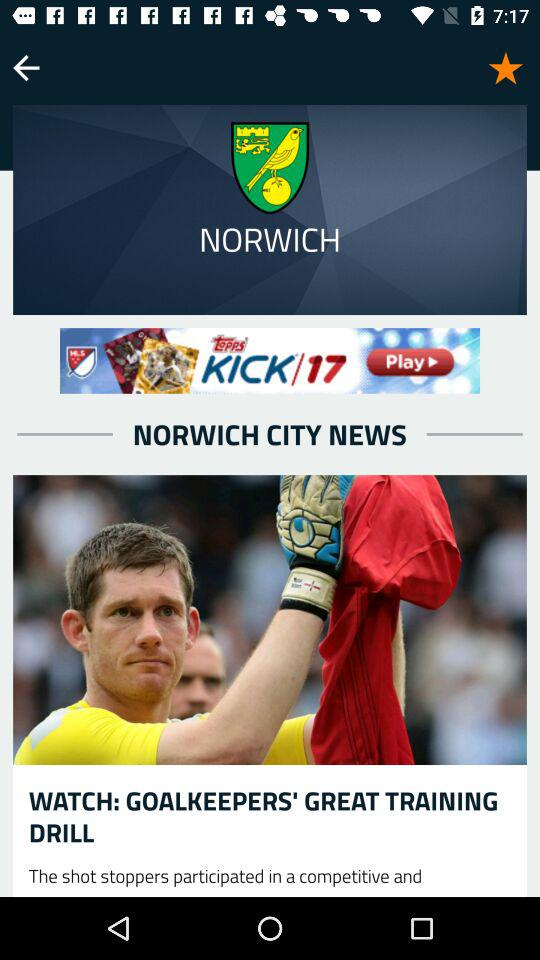What is the name of the news channel? The news channel name is "NORWICH". 